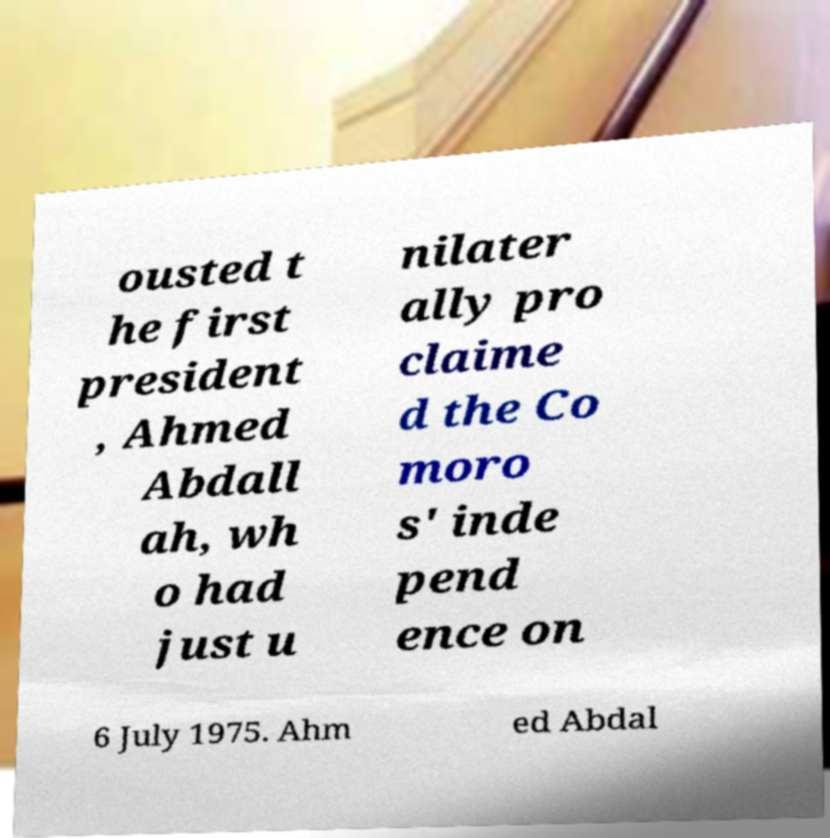I need the written content from this picture converted into text. Can you do that? ousted t he first president , Ahmed Abdall ah, wh o had just u nilater ally pro claime d the Co moro s' inde pend ence on 6 July 1975. Ahm ed Abdal 